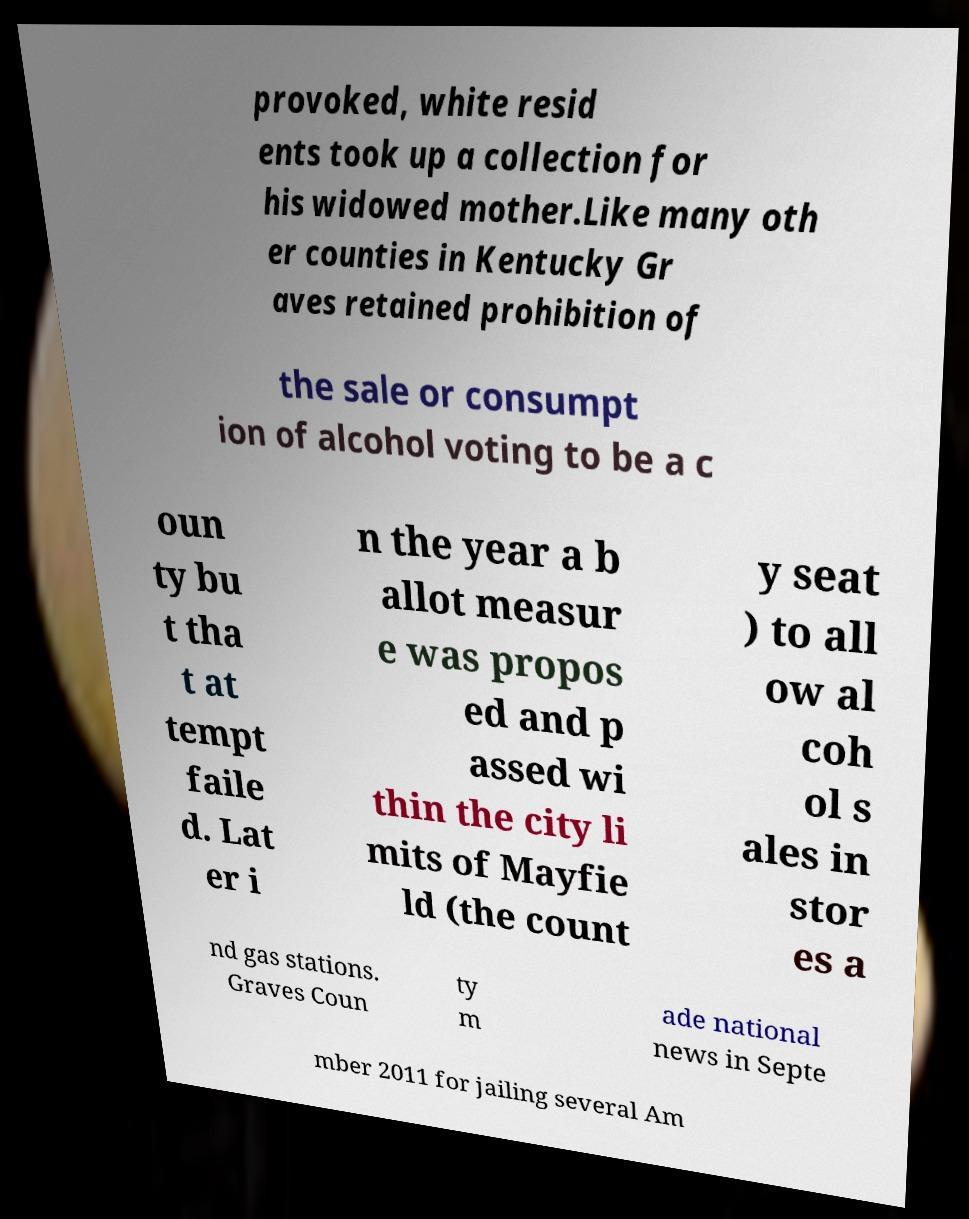Please read and relay the text visible in this image. What does it say? provoked, white resid ents took up a collection for his widowed mother.Like many oth er counties in Kentucky Gr aves retained prohibition of the sale or consumpt ion of alcohol voting to be a c oun ty bu t tha t at tempt faile d. Lat er i n the year a b allot measur e was propos ed and p assed wi thin the city li mits of Mayfie ld (the count y seat ) to all ow al coh ol s ales in stor es a nd gas stations. Graves Coun ty m ade national news in Septe mber 2011 for jailing several Am 